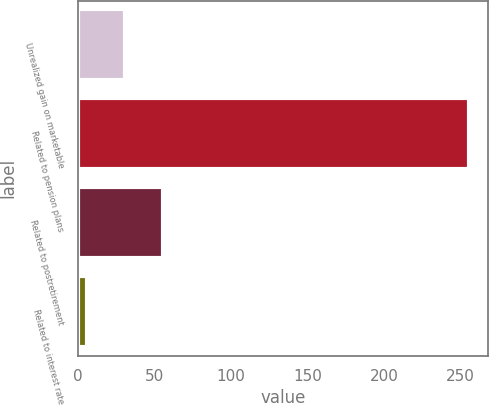<chart> <loc_0><loc_0><loc_500><loc_500><bar_chart><fcel>Unrealized gain on marketable<fcel>Related to pension plans<fcel>Related to postretirement<fcel>Related to interest rate<nl><fcel>30.49<fcel>255.4<fcel>55.48<fcel>5.5<nl></chart> 